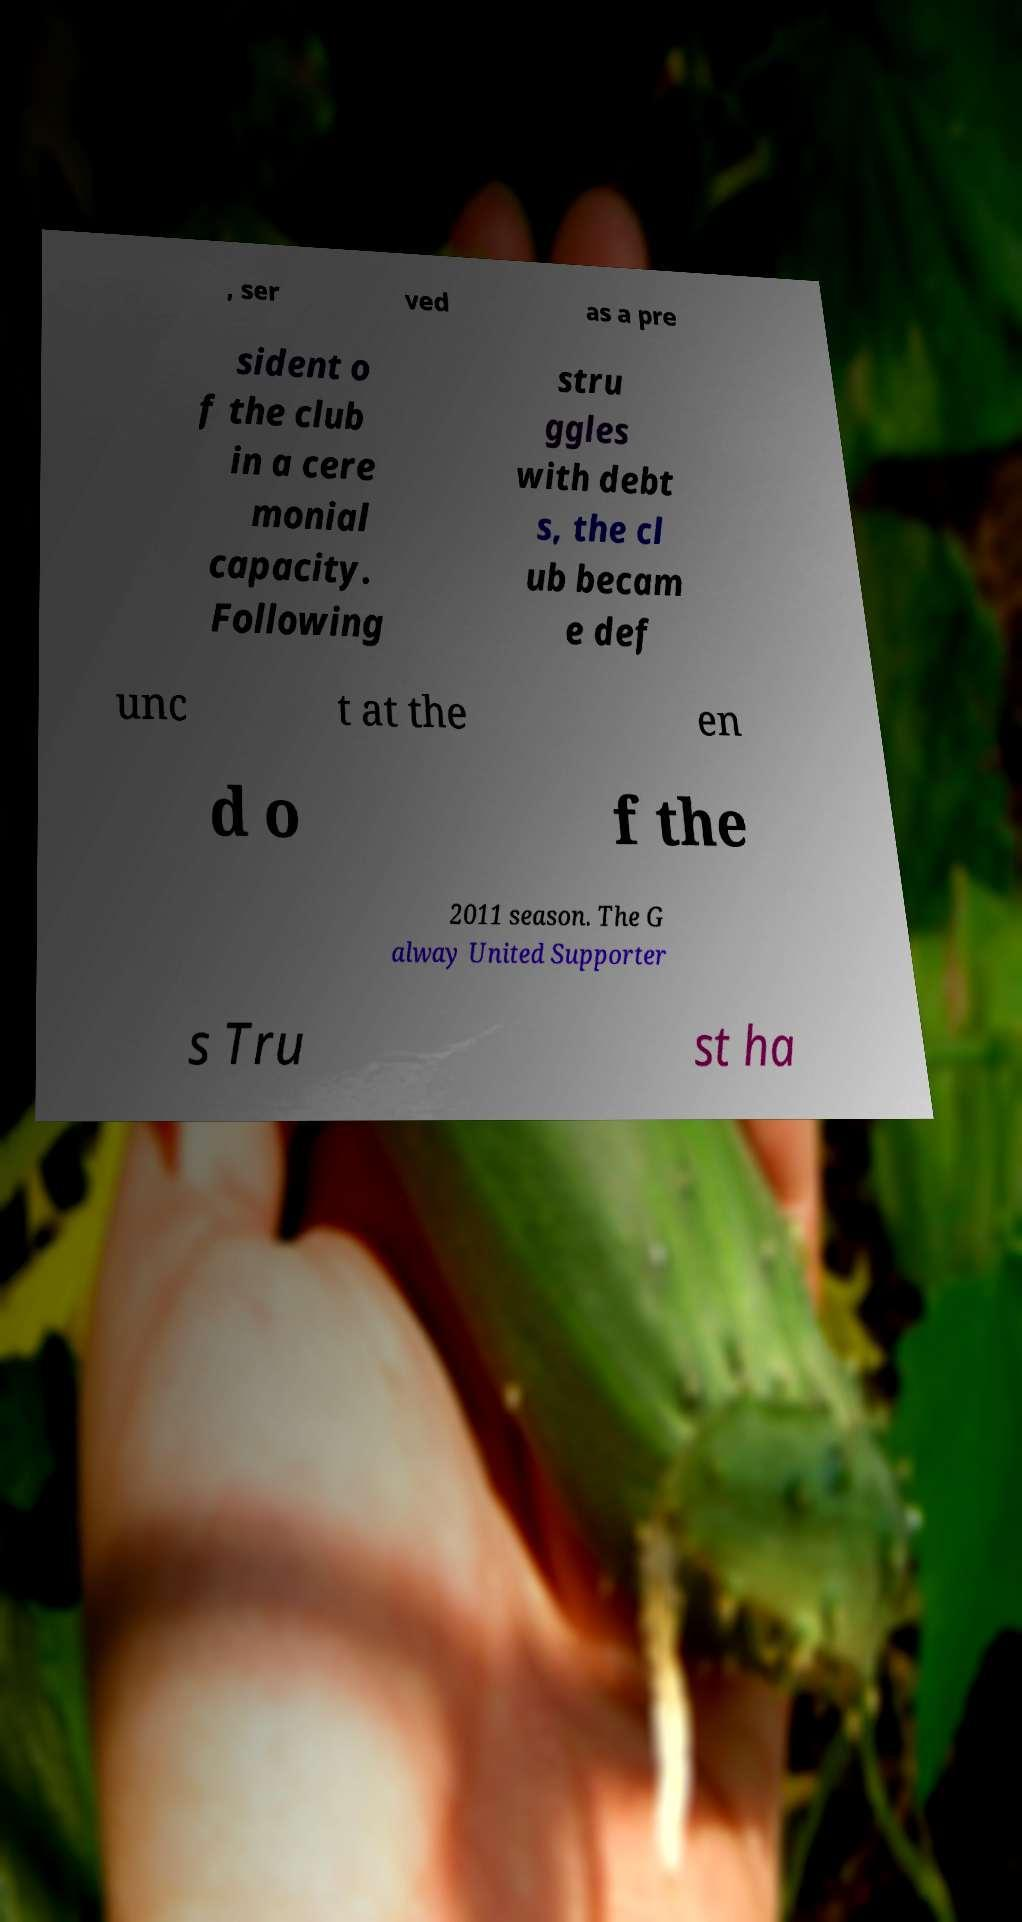What messages or text are displayed in this image? I need them in a readable, typed format. , ser ved as a pre sident o f the club in a cere monial capacity. Following stru ggles with debt s, the cl ub becam e def unc t at the en d o f the 2011 season. The G alway United Supporter s Tru st ha 